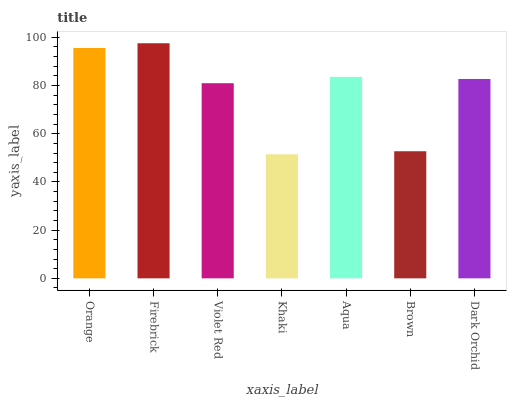Is Khaki the minimum?
Answer yes or no. Yes. Is Firebrick the maximum?
Answer yes or no. Yes. Is Violet Red the minimum?
Answer yes or no. No. Is Violet Red the maximum?
Answer yes or no. No. Is Firebrick greater than Violet Red?
Answer yes or no. Yes. Is Violet Red less than Firebrick?
Answer yes or no. Yes. Is Violet Red greater than Firebrick?
Answer yes or no. No. Is Firebrick less than Violet Red?
Answer yes or no. No. Is Dark Orchid the high median?
Answer yes or no. Yes. Is Dark Orchid the low median?
Answer yes or no. Yes. Is Aqua the high median?
Answer yes or no. No. Is Firebrick the low median?
Answer yes or no. No. 